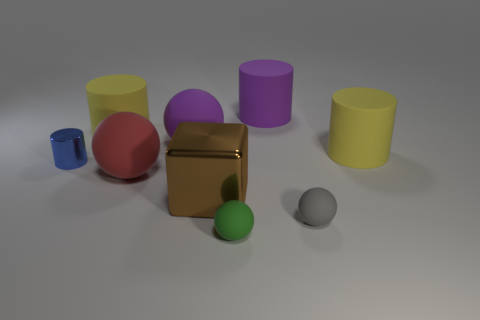How big is the ball that is behind the tiny cylinder?
Make the answer very short. Large. Are there any large purple spheres that are right of the matte ball behind the red matte thing?
Provide a short and direct response. No. Is the color of the tiny shiny object that is behind the green ball the same as the big sphere on the right side of the big red rubber thing?
Offer a very short reply. No. What is the color of the tiny cylinder?
Ensure brevity in your answer.  Blue. There is a large matte cylinder that is in front of the large purple cylinder and on the right side of the block; what is its color?
Give a very brief answer. Yellow. There is a yellow rubber thing on the left side of the purple rubber cylinder; is its size the same as the blue cylinder?
Provide a succinct answer. No. Is the number of large cylinders to the right of the tiny gray rubber ball greater than the number of tiny brown things?
Provide a succinct answer. Yes. Is the gray rubber object the same shape as the large red object?
Keep it short and to the point. Yes. How big is the green rubber sphere?
Provide a succinct answer. Small. Is the number of yellow matte cylinders that are behind the green object greater than the number of blue objects that are behind the metal cylinder?
Your answer should be compact. Yes. 